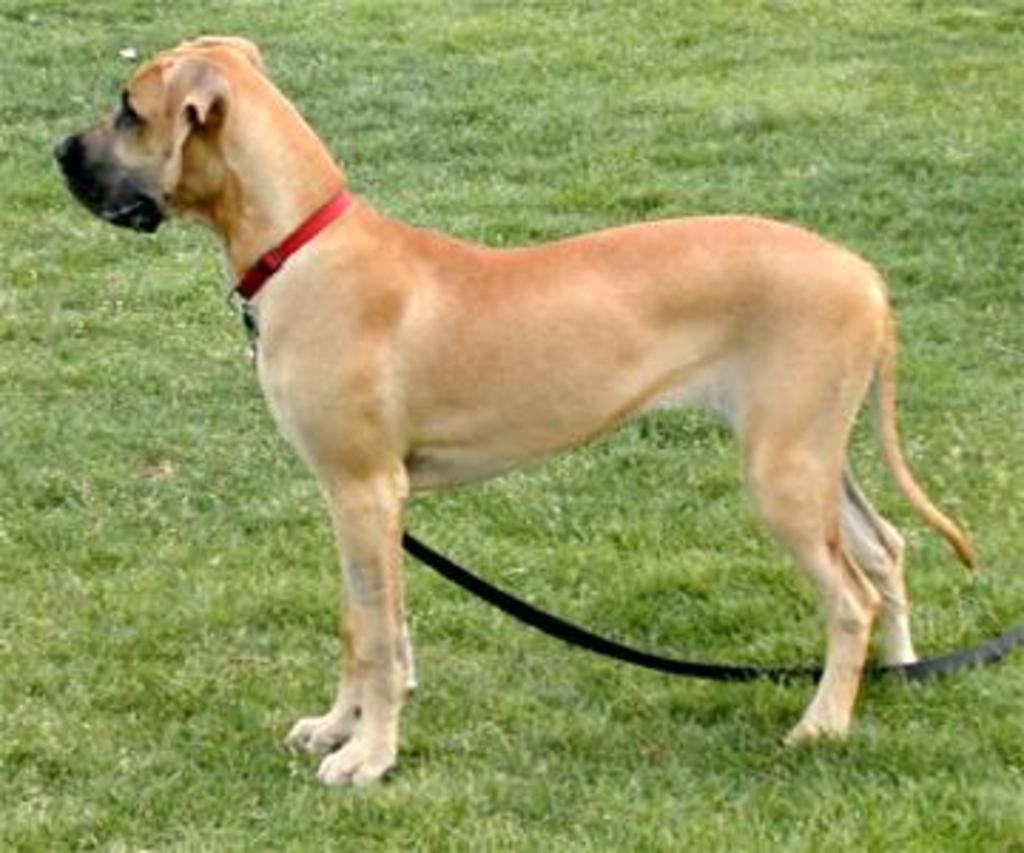What animal can be seen in the image? There is a dog in the image. Where is the dog located? The dog is standing on the grass. Does the dog have any accessories? Yes, the dog has a collar rope. What type of vegetation is visible in the background of the image? There is grass visible in the background of the image. What type of feather can be seen on the dog's back in the image? There is no feather present on the dog's back in the image. What type of wall can be seen behind the dog in the image? There is no wall visible in the image; it features a dog standing on grass. 